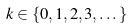<formula> <loc_0><loc_0><loc_500><loc_500>k \in \{ 0 , 1 , 2 , 3 , \dots \}</formula> 